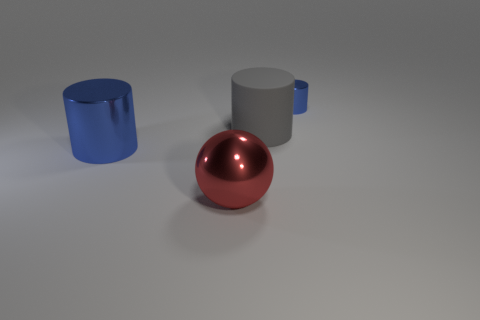Subtract all large rubber cylinders. How many cylinders are left? 2 Add 3 tiny yellow matte cylinders. How many objects exist? 7 Subtract all cylinders. How many objects are left? 1 Subtract all gray cylinders. How many cylinders are left? 2 Subtract 1 gray cylinders. How many objects are left? 3 Subtract 1 cylinders. How many cylinders are left? 2 Subtract all cyan cylinders. Subtract all yellow spheres. How many cylinders are left? 3 Subtract all yellow cylinders. How many gray balls are left? 0 Subtract all rubber things. Subtract all metallic things. How many objects are left? 0 Add 4 blue shiny things. How many blue shiny things are left? 6 